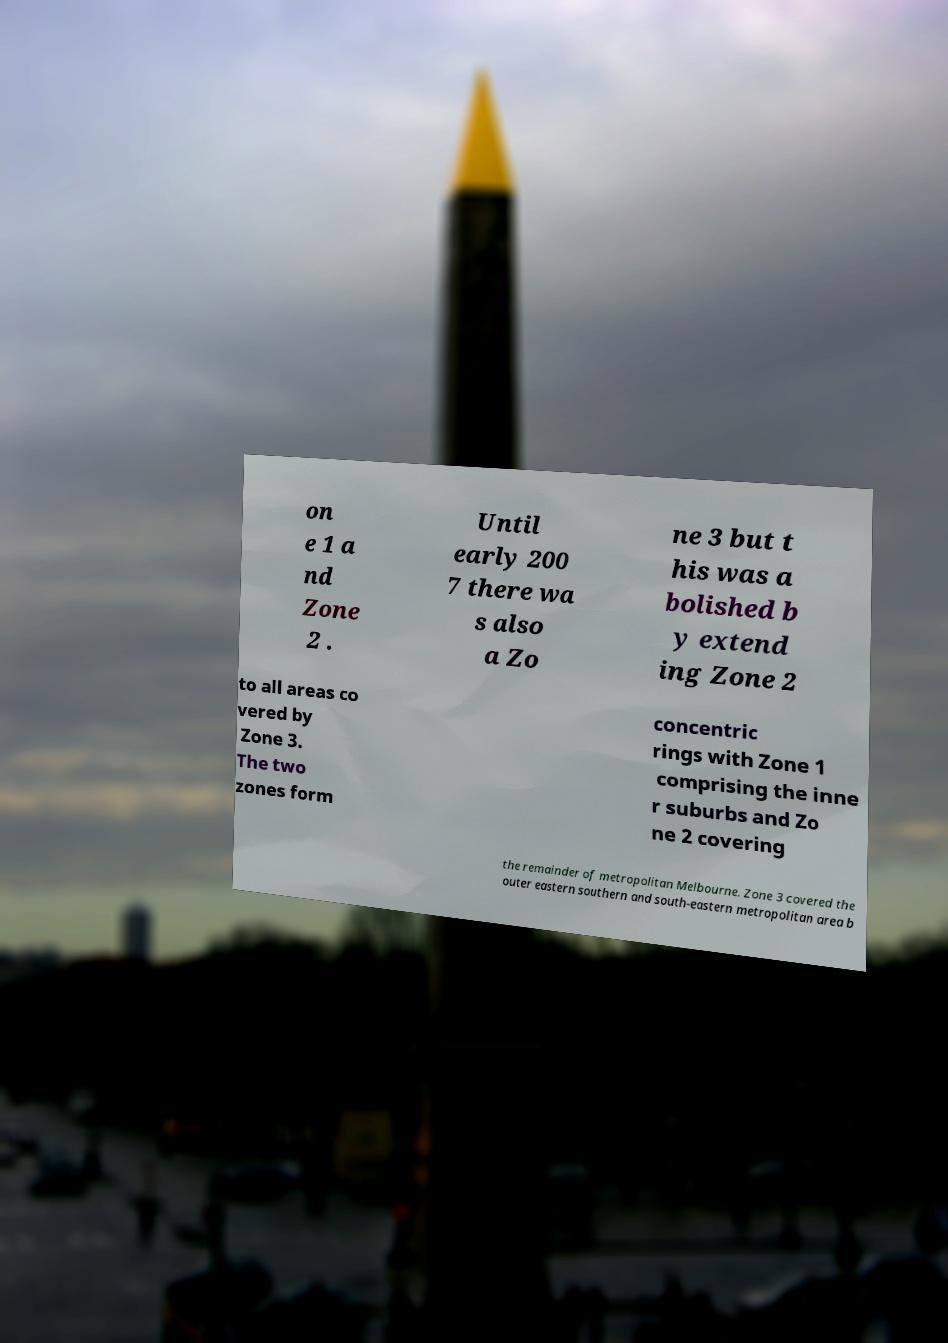Can you accurately transcribe the text from the provided image for me? on e 1 a nd Zone 2 . Until early 200 7 there wa s also a Zo ne 3 but t his was a bolished b y extend ing Zone 2 to all areas co vered by Zone 3. The two zones form concentric rings with Zone 1 comprising the inne r suburbs and Zo ne 2 covering the remainder of metropolitan Melbourne. Zone 3 covered the outer eastern southern and south-eastern metropolitan area b 